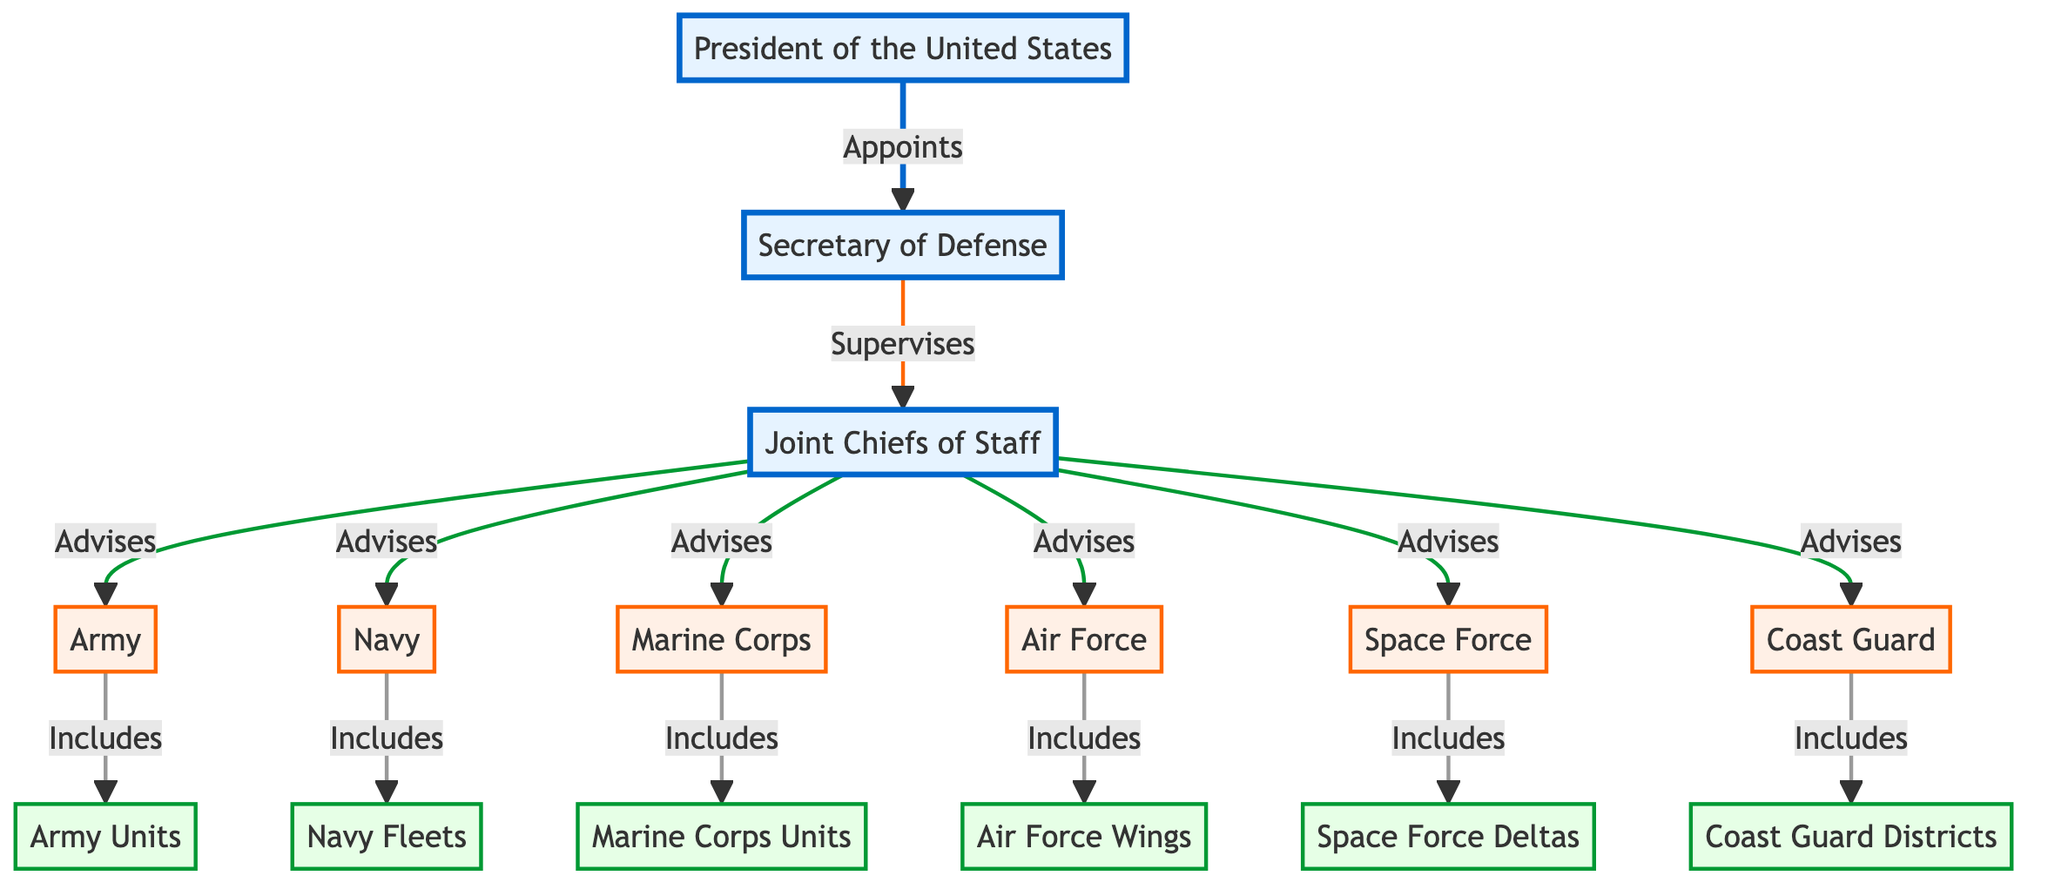What is the highest position in the U.S. Armed Forces hierarchy? The highest position in the hierarchy is the President of the United States, which is the top node in the diagram indicating the ultimate authority over the armed forces.
Answer: President of the United States How many branches of the U.S. Armed Forces are represented in the diagram? There are six branches of the U.S. Armed Forces represented: Army, Navy, Marine Corps, Air Force, Space Force, and Coast Guard, each indicated at the second level of the hierarchy.
Answer: 6 Which entity is supervised by the Secretary of Defense? The diagram shows that the Secretary of Defense supervises the Joint Chiefs of Staff, represented by the connecting edge between them, indicating a direct supervisory relationship.
Answer: Joint Chiefs of Staff What is the relationship between the Army and Army Units? The relationship is that the Army includes Army Units, as represented by the phrase "Includes" connecting the Army node to Army Units, indicating a hierarchical structure where the Army encompasses its units.
Answer: Includes How many units or fleets fall under the U.S. Navy? The diagram specifies that the U.S. Navy includes Navy Fleets, identifying it as the unit type under the Navy, therefore there is one type of unit specified.
Answer: 1 What role do the Joint Chiefs of Staff play in relation to the branches of the U.S. Armed Forces? The Joint Chiefs of Staff advise all branches of the U.S. Armed Forces, as implied by the connecting relationship shown in the diagram from Joint Chiefs of Staff to Army, Navy, Marine Corps, Air Force, Space Force, and Coast Guard.
Answer: Advises List the lowest level of organizational structure represented in the diagram. The lowest level of the organizational structure consists of specific units like Army Units, Navy Fleets, Marine Corps Units, Air Force Wings, Space Force Deltas, and Coast Guard Districts, indicating sub-divisions within each branch.
Answer: Army Units, Navy Fleets, Marine Corps Units, Air Force Wings, Space Force Deltas, Coast Guard Districts What color represents the first level of the hierarchy? The first level of the hierarchy, which includes the President of the United States, Secretary of Defense, and Joint Chiefs of Staff, is represented in blue, as indicated by the class definition for level 1 in the diagram.
Answer: Blue How is the Secretary of Defense appointed? The diagram indicates that the Secretary of Defense is appointed by the President of the United States, establishing a direct hierarchical link showing the flow of authority.
Answer: Appoints 